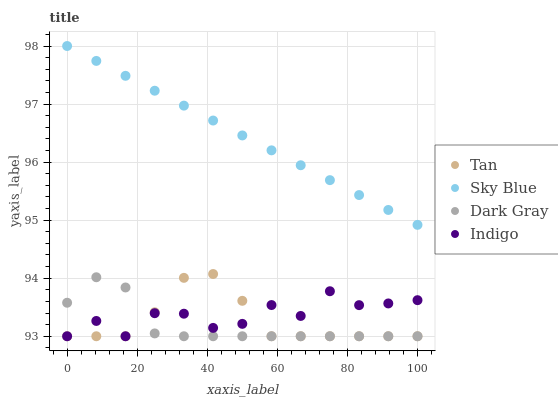Does Dark Gray have the minimum area under the curve?
Answer yes or no. Yes. Does Sky Blue have the maximum area under the curve?
Answer yes or no. Yes. Does Tan have the minimum area under the curve?
Answer yes or no. No. Does Tan have the maximum area under the curve?
Answer yes or no. No. Is Sky Blue the smoothest?
Answer yes or no. Yes. Is Indigo the roughest?
Answer yes or no. Yes. Is Tan the smoothest?
Answer yes or no. No. Is Tan the roughest?
Answer yes or no. No. Does Dark Gray have the lowest value?
Answer yes or no. Yes. Does Sky Blue have the lowest value?
Answer yes or no. No. Does Sky Blue have the highest value?
Answer yes or no. Yes. Does Tan have the highest value?
Answer yes or no. No. Is Indigo less than Sky Blue?
Answer yes or no. Yes. Is Sky Blue greater than Dark Gray?
Answer yes or no. Yes. Does Indigo intersect Dark Gray?
Answer yes or no. Yes. Is Indigo less than Dark Gray?
Answer yes or no. No. Is Indigo greater than Dark Gray?
Answer yes or no. No. Does Indigo intersect Sky Blue?
Answer yes or no. No. 